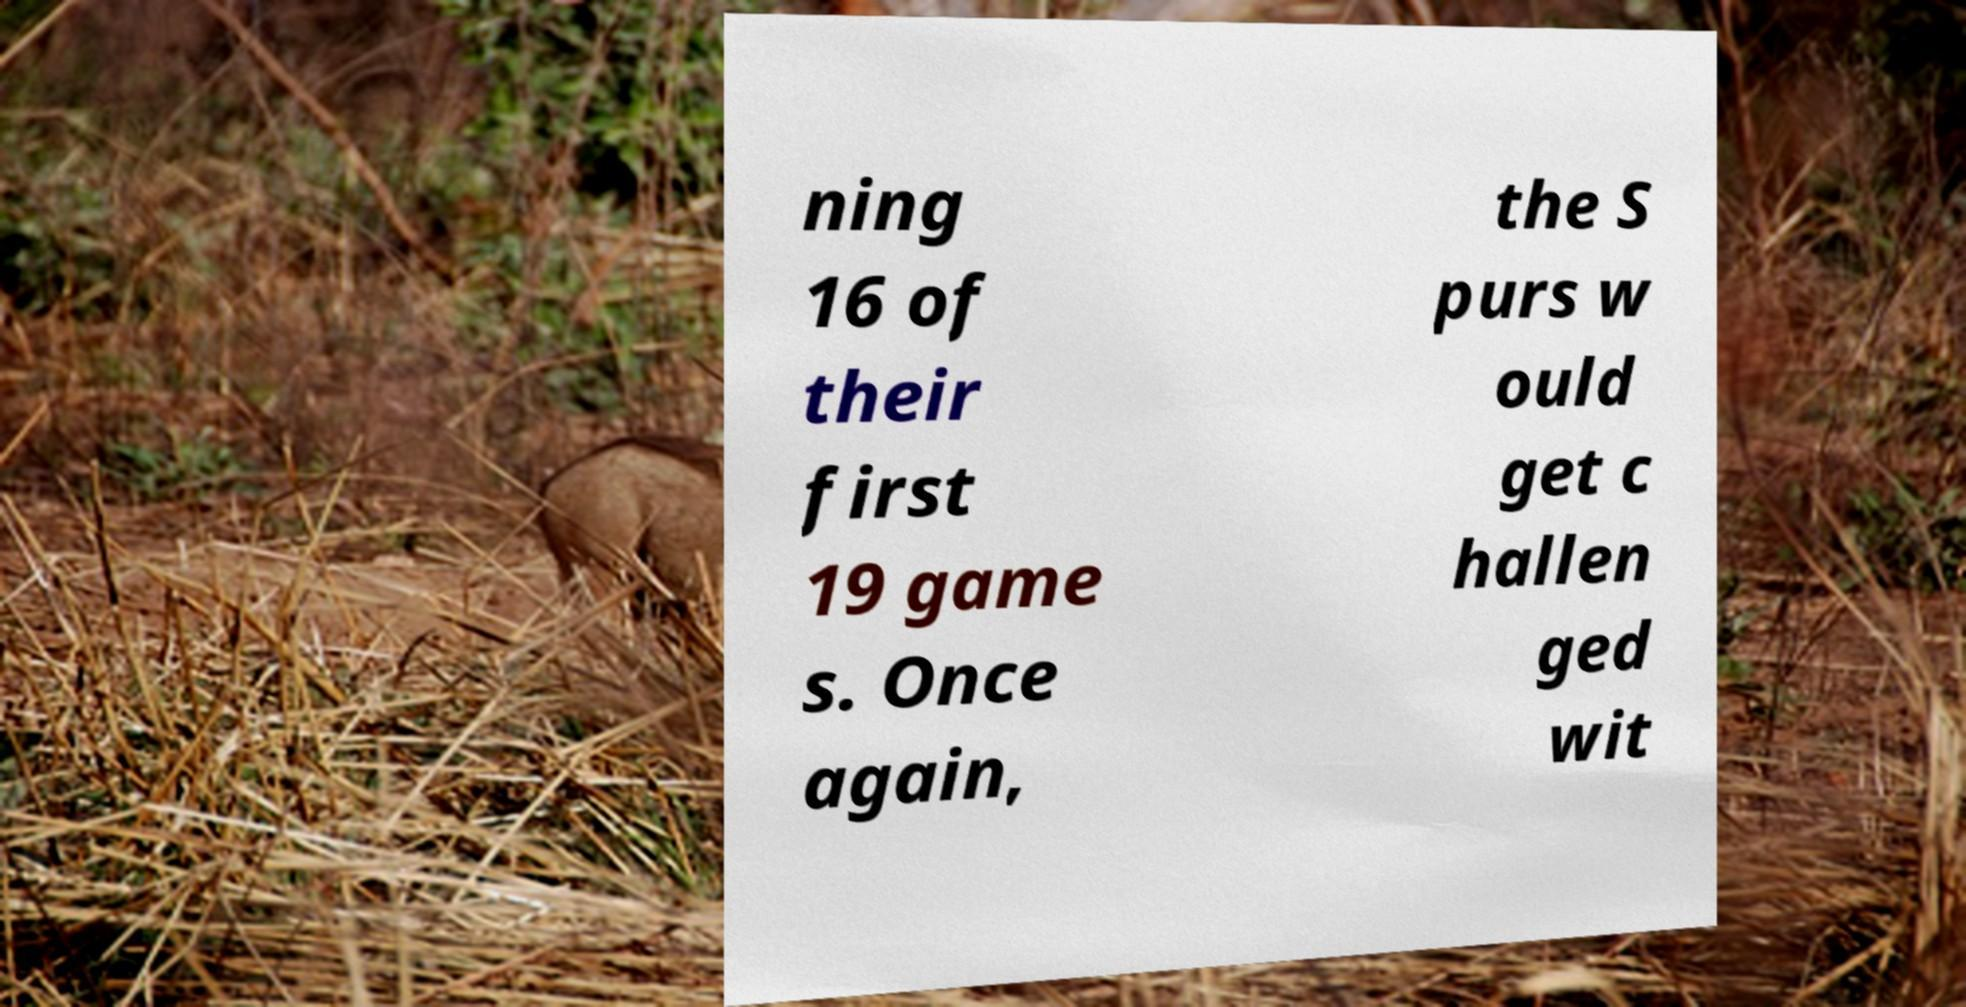Can you read and provide the text displayed in the image?This photo seems to have some interesting text. Can you extract and type it out for me? ning 16 of their first 19 game s. Once again, the S purs w ould get c hallen ged wit 